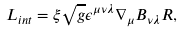<formula> <loc_0><loc_0><loc_500><loc_500>L _ { i n t } = \xi \sqrt { g } \epsilon ^ { \mu \nu \lambda } \nabla _ { \mu } B _ { \nu \lambda } R ,</formula> 